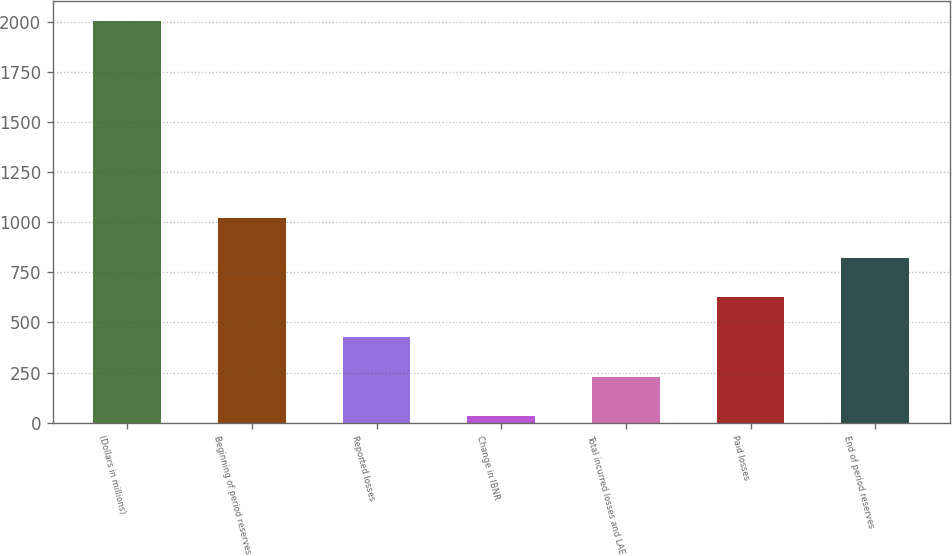<chart> <loc_0><loc_0><loc_500><loc_500><bar_chart><fcel>(Dollars in millions)<fcel>Beginning of period reserves<fcel>Reported losses<fcel>Change in IBNR<fcel>Total incurred losses and LAE<fcel>Paid losses<fcel>End of period reserves<nl><fcel>2005<fcel>1019.05<fcel>427.48<fcel>33.1<fcel>230.29<fcel>624.67<fcel>821.86<nl></chart> 